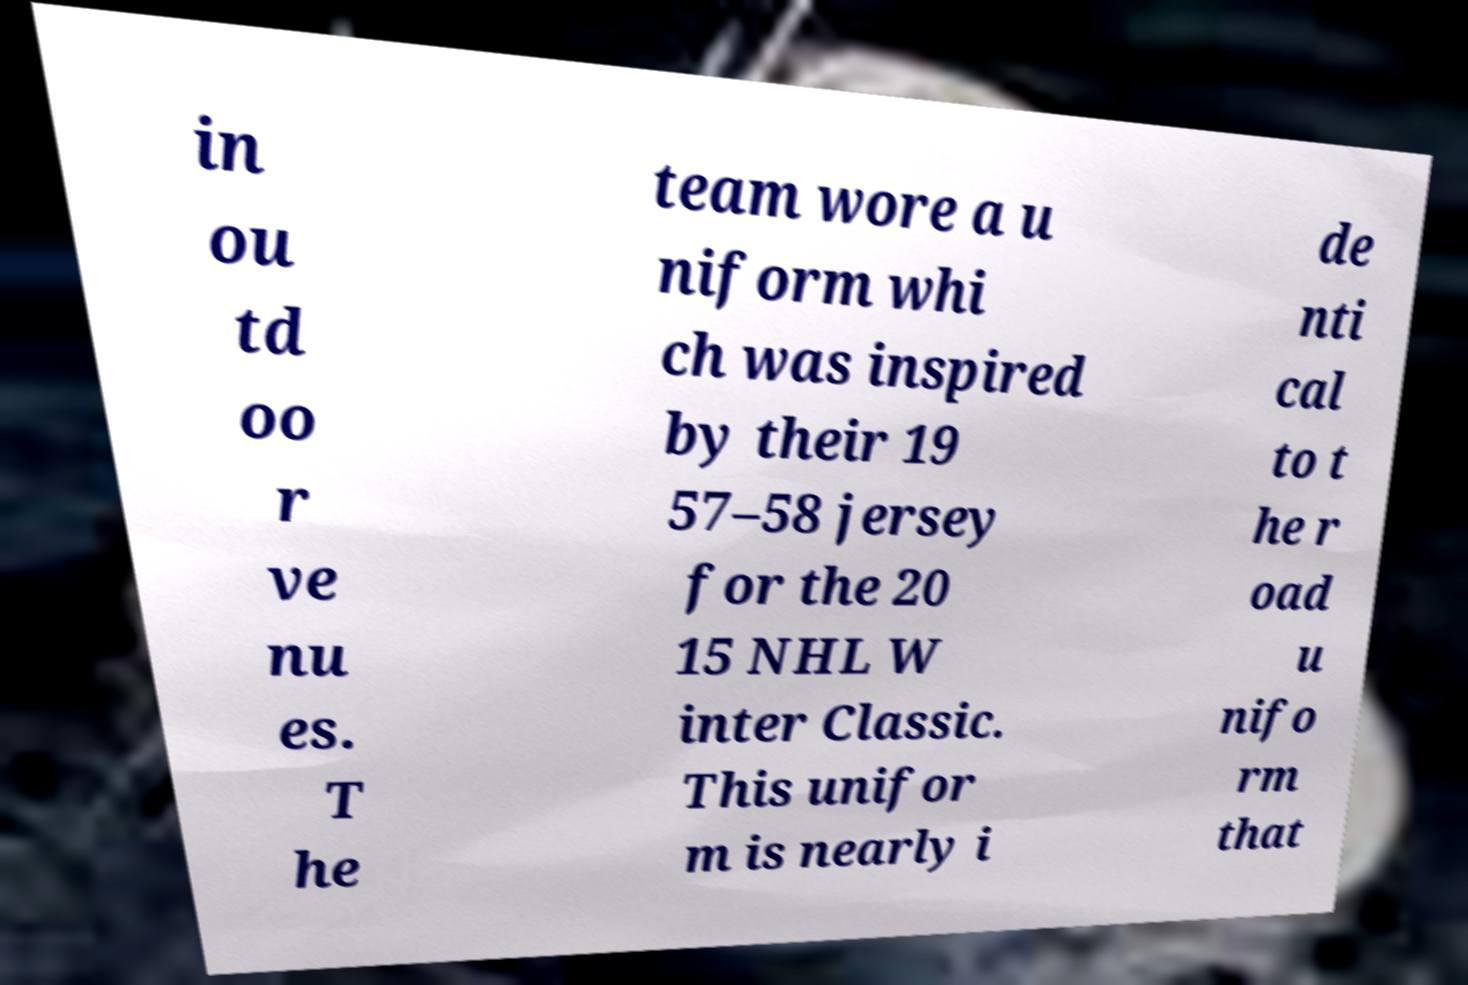For documentation purposes, I need the text within this image transcribed. Could you provide that? in ou td oo r ve nu es. T he team wore a u niform whi ch was inspired by their 19 57–58 jersey for the 20 15 NHL W inter Classic. This unifor m is nearly i de nti cal to t he r oad u nifo rm that 